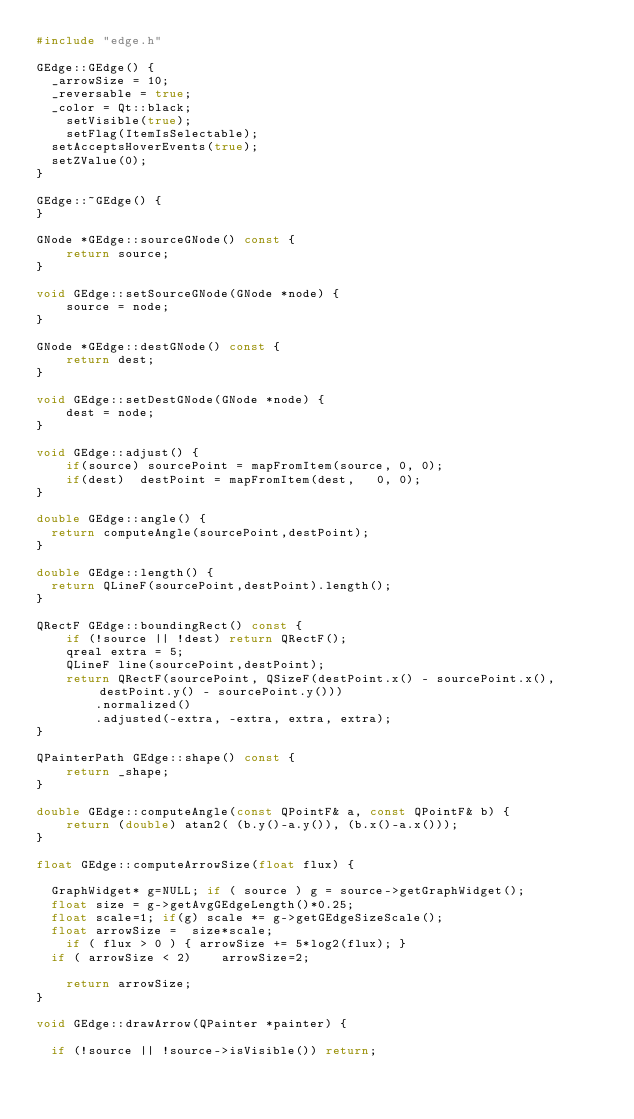<code> <loc_0><loc_0><loc_500><loc_500><_C++_>#include "edge.h"

GEdge::GEdge() {
	_arrowSize = 10;
	_reversable = true;
	_color = Qt::black;
    setVisible(true);
    setFlag(ItemIsSelectable);
	setAcceptsHoverEvents(true);
	setZValue(0);
}

GEdge::~GEdge() {
}

GNode *GEdge::sourceGNode() const {
    return source;
}

void GEdge::setSourceGNode(GNode *node) {
    source = node;
}

GNode *GEdge::destGNode() const {
    return dest;
}

void GEdge::setDestGNode(GNode *node) {
    dest = node;
}

void GEdge::adjust() {
    if(source) sourcePoint = mapFromItem(source, 0, 0);
    if(dest)  destPoint = mapFromItem(dest,   0, 0);
}

double GEdge::angle() { 
	return computeAngle(sourcePoint,destPoint);
}

double GEdge::length() { 
	return QLineF(sourcePoint,destPoint).length();
}

QRectF GEdge::boundingRect() const {
    if (!source || !dest) return QRectF();
    qreal extra = 5;
    QLineF line(sourcePoint,destPoint);
    return QRectF(sourcePoint, QSizeF(destPoint.x() - sourcePoint.x(), destPoint.y() - sourcePoint.y()))
        .normalized()
        .adjusted(-extra, -extra, extra, extra);
}

QPainterPath GEdge::shape() const {
		return _shape;
}

double GEdge::computeAngle(const QPointF& a, const QPointF& b) { 
    return (double) atan2( (b.y()-a.y()), (b.x()-a.x()));
}

float GEdge::computeArrowSize(float flux) { 

	GraphWidget* g=NULL; if ( source ) g = source->getGraphWidget();
	float size = g->getAvgGEdgeLength()*0.25;
	float scale=1; if(g) scale *= g->getGEdgeSizeScale();
	float arrowSize =  size*scale;
    if ( flux > 0 ) { arrowSize += 5*log2(flux); }
	if ( arrowSize < 2)    arrowSize=2;

    return arrowSize;
}

void GEdge::drawArrow(QPainter *painter) {

	if (!source || !source->isVisible()) return;</code> 